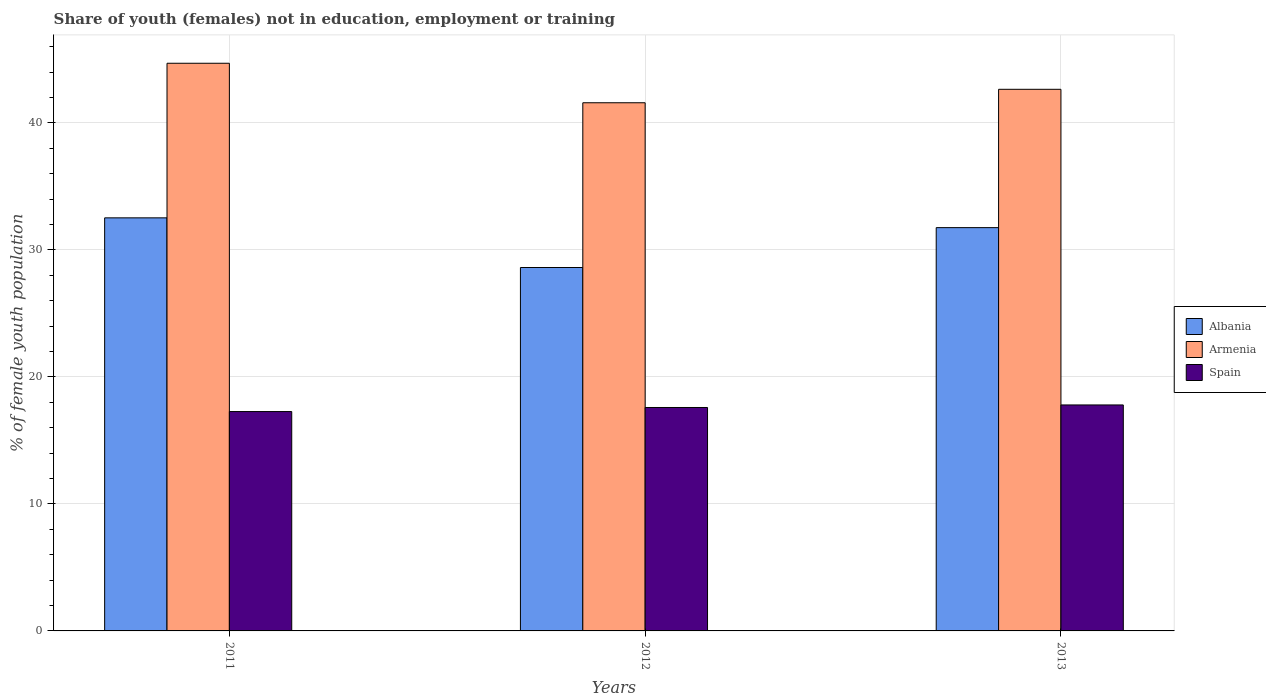Are the number of bars per tick equal to the number of legend labels?
Make the answer very short. Yes. Are the number of bars on each tick of the X-axis equal?
Make the answer very short. Yes. How many bars are there on the 3rd tick from the left?
Ensure brevity in your answer.  3. How many bars are there on the 2nd tick from the right?
Your response must be concise. 3. What is the label of the 1st group of bars from the left?
Give a very brief answer. 2011. What is the percentage of unemployed female population in in Armenia in 2011?
Give a very brief answer. 44.69. Across all years, what is the maximum percentage of unemployed female population in in Armenia?
Your answer should be very brief. 44.69. Across all years, what is the minimum percentage of unemployed female population in in Albania?
Offer a very short reply. 28.61. In which year was the percentage of unemployed female population in in Armenia minimum?
Provide a short and direct response. 2012. What is the total percentage of unemployed female population in in Armenia in the graph?
Provide a short and direct response. 128.91. What is the difference between the percentage of unemployed female population in in Albania in 2011 and that in 2013?
Keep it short and to the point. 0.77. What is the difference between the percentage of unemployed female population in in Spain in 2012 and the percentage of unemployed female population in in Armenia in 2013?
Give a very brief answer. -25.05. What is the average percentage of unemployed female population in in Albania per year?
Keep it short and to the point. 30.96. In the year 2013, what is the difference between the percentage of unemployed female population in in Albania and percentage of unemployed female population in in Armenia?
Your answer should be very brief. -10.89. What is the ratio of the percentage of unemployed female population in in Spain in 2012 to that in 2013?
Keep it short and to the point. 0.99. Is the percentage of unemployed female population in in Armenia in 2011 less than that in 2012?
Your answer should be very brief. No. What is the difference between the highest and the second highest percentage of unemployed female population in in Spain?
Keep it short and to the point. 0.2. What is the difference between the highest and the lowest percentage of unemployed female population in in Spain?
Offer a very short reply. 0.52. Is the sum of the percentage of unemployed female population in in Albania in 2012 and 2013 greater than the maximum percentage of unemployed female population in in Armenia across all years?
Keep it short and to the point. Yes. What does the 2nd bar from the left in 2012 represents?
Provide a succinct answer. Armenia. Are all the bars in the graph horizontal?
Make the answer very short. No. How many legend labels are there?
Provide a short and direct response. 3. How are the legend labels stacked?
Keep it short and to the point. Vertical. What is the title of the graph?
Offer a terse response. Share of youth (females) not in education, employment or training. What is the label or title of the Y-axis?
Offer a terse response. % of female youth population. What is the % of female youth population in Albania in 2011?
Your answer should be very brief. 32.52. What is the % of female youth population in Armenia in 2011?
Offer a terse response. 44.69. What is the % of female youth population in Spain in 2011?
Give a very brief answer. 17.27. What is the % of female youth population of Albania in 2012?
Offer a terse response. 28.61. What is the % of female youth population in Armenia in 2012?
Provide a short and direct response. 41.58. What is the % of female youth population in Spain in 2012?
Provide a succinct answer. 17.59. What is the % of female youth population of Albania in 2013?
Keep it short and to the point. 31.75. What is the % of female youth population in Armenia in 2013?
Your response must be concise. 42.64. What is the % of female youth population in Spain in 2013?
Offer a terse response. 17.79. Across all years, what is the maximum % of female youth population in Albania?
Your answer should be compact. 32.52. Across all years, what is the maximum % of female youth population in Armenia?
Your response must be concise. 44.69. Across all years, what is the maximum % of female youth population in Spain?
Your response must be concise. 17.79. Across all years, what is the minimum % of female youth population in Albania?
Provide a short and direct response. 28.61. Across all years, what is the minimum % of female youth population in Armenia?
Keep it short and to the point. 41.58. Across all years, what is the minimum % of female youth population of Spain?
Offer a terse response. 17.27. What is the total % of female youth population in Albania in the graph?
Keep it short and to the point. 92.88. What is the total % of female youth population of Armenia in the graph?
Keep it short and to the point. 128.91. What is the total % of female youth population in Spain in the graph?
Offer a very short reply. 52.65. What is the difference between the % of female youth population in Albania in 2011 and that in 2012?
Offer a terse response. 3.91. What is the difference between the % of female youth population in Armenia in 2011 and that in 2012?
Keep it short and to the point. 3.11. What is the difference between the % of female youth population in Spain in 2011 and that in 2012?
Your answer should be very brief. -0.32. What is the difference between the % of female youth population of Albania in 2011 and that in 2013?
Offer a very short reply. 0.77. What is the difference between the % of female youth population of Armenia in 2011 and that in 2013?
Keep it short and to the point. 2.05. What is the difference between the % of female youth population of Spain in 2011 and that in 2013?
Your response must be concise. -0.52. What is the difference between the % of female youth population of Albania in 2012 and that in 2013?
Your answer should be very brief. -3.14. What is the difference between the % of female youth population in Armenia in 2012 and that in 2013?
Give a very brief answer. -1.06. What is the difference between the % of female youth population in Spain in 2012 and that in 2013?
Provide a short and direct response. -0.2. What is the difference between the % of female youth population in Albania in 2011 and the % of female youth population in Armenia in 2012?
Make the answer very short. -9.06. What is the difference between the % of female youth population in Albania in 2011 and the % of female youth population in Spain in 2012?
Ensure brevity in your answer.  14.93. What is the difference between the % of female youth population of Armenia in 2011 and the % of female youth population of Spain in 2012?
Ensure brevity in your answer.  27.1. What is the difference between the % of female youth population of Albania in 2011 and the % of female youth population of Armenia in 2013?
Offer a terse response. -10.12. What is the difference between the % of female youth population in Albania in 2011 and the % of female youth population in Spain in 2013?
Offer a terse response. 14.73. What is the difference between the % of female youth population of Armenia in 2011 and the % of female youth population of Spain in 2013?
Your answer should be compact. 26.9. What is the difference between the % of female youth population of Albania in 2012 and the % of female youth population of Armenia in 2013?
Your answer should be compact. -14.03. What is the difference between the % of female youth population of Albania in 2012 and the % of female youth population of Spain in 2013?
Provide a succinct answer. 10.82. What is the difference between the % of female youth population of Armenia in 2012 and the % of female youth population of Spain in 2013?
Offer a very short reply. 23.79. What is the average % of female youth population of Albania per year?
Provide a succinct answer. 30.96. What is the average % of female youth population in Armenia per year?
Your answer should be very brief. 42.97. What is the average % of female youth population of Spain per year?
Offer a terse response. 17.55. In the year 2011, what is the difference between the % of female youth population of Albania and % of female youth population of Armenia?
Your answer should be compact. -12.17. In the year 2011, what is the difference between the % of female youth population of Albania and % of female youth population of Spain?
Provide a short and direct response. 15.25. In the year 2011, what is the difference between the % of female youth population in Armenia and % of female youth population in Spain?
Offer a very short reply. 27.42. In the year 2012, what is the difference between the % of female youth population of Albania and % of female youth population of Armenia?
Make the answer very short. -12.97. In the year 2012, what is the difference between the % of female youth population in Albania and % of female youth population in Spain?
Ensure brevity in your answer.  11.02. In the year 2012, what is the difference between the % of female youth population in Armenia and % of female youth population in Spain?
Offer a terse response. 23.99. In the year 2013, what is the difference between the % of female youth population in Albania and % of female youth population in Armenia?
Your answer should be very brief. -10.89. In the year 2013, what is the difference between the % of female youth population of Albania and % of female youth population of Spain?
Your answer should be compact. 13.96. In the year 2013, what is the difference between the % of female youth population of Armenia and % of female youth population of Spain?
Your answer should be very brief. 24.85. What is the ratio of the % of female youth population of Albania in 2011 to that in 2012?
Ensure brevity in your answer.  1.14. What is the ratio of the % of female youth population of Armenia in 2011 to that in 2012?
Provide a succinct answer. 1.07. What is the ratio of the % of female youth population in Spain in 2011 to that in 2012?
Your response must be concise. 0.98. What is the ratio of the % of female youth population of Albania in 2011 to that in 2013?
Provide a short and direct response. 1.02. What is the ratio of the % of female youth population in Armenia in 2011 to that in 2013?
Your response must be concise. 1.05. What is the ratio of the % of female youth population of Spain in 2011 to that in 2013?
Provide a short and direct response. 0.97. What is the ratio of the % of female youth population of Albania in 2012 to that in 2013?
Keep it short and to the point. 0.9. What is the ratio of the % of female youth population of Armenia in 2012 to that in 2013?
Give a very brief answer. 0.98. What is the ratio of the % of female youth population of Spain in 2012 to that in 2013?
Provide a short and direct response. 0.99. What is the difference between the highest and the second highest % of female youth population in Albania?
Your answer should be very brief. 0.77. What is the difference between the highest and the second highest % of female youth population in Armenia?
Offer a very short reply. 2.05. What is the difference between the highest and the lowest % of female youth population of Albania?
Offer a very short reply. 3.91. What is the difference between the highest and the lowest % of female youth population in Armenia?
Give a very brief answer. 3.11. What is the difference between the highest and the lowest % of female youth population in Spain?
Provide a short and direct response. 0.52. 